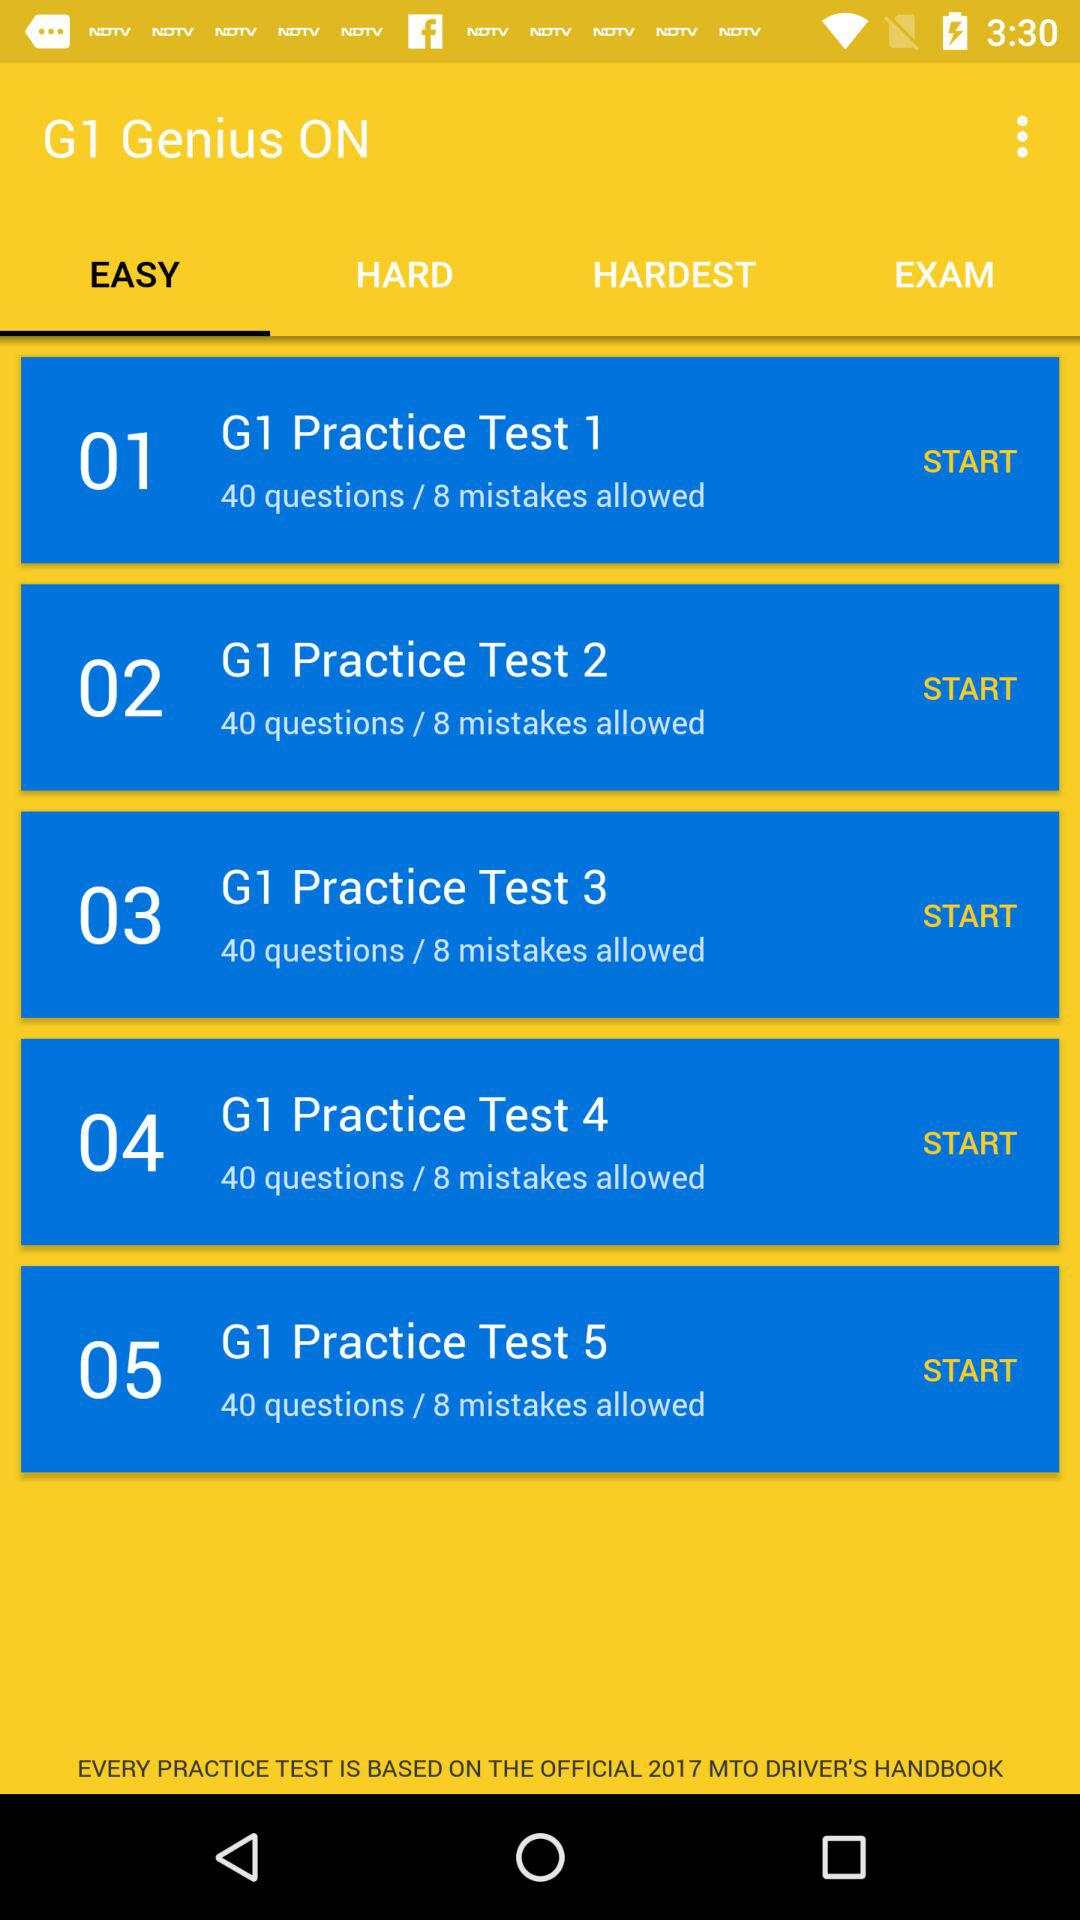How many practice tests are there?
Answer the question using a single word or phrase. 5 